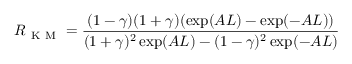<formula> <loc_0><loc_0><loc_500><loc_500>R _ { K M } = \frac { ( 1 - \gamma ) ( 1 + \gamma ) ( \exp ( A L ) - \exp ( - A L ) ) } { ( 1 + \gamma ) ^ { 2 } \exp ( A L ) - ( 1 - \gamma ) ^ { 2 } \exp ( - A L ) }</formula> 